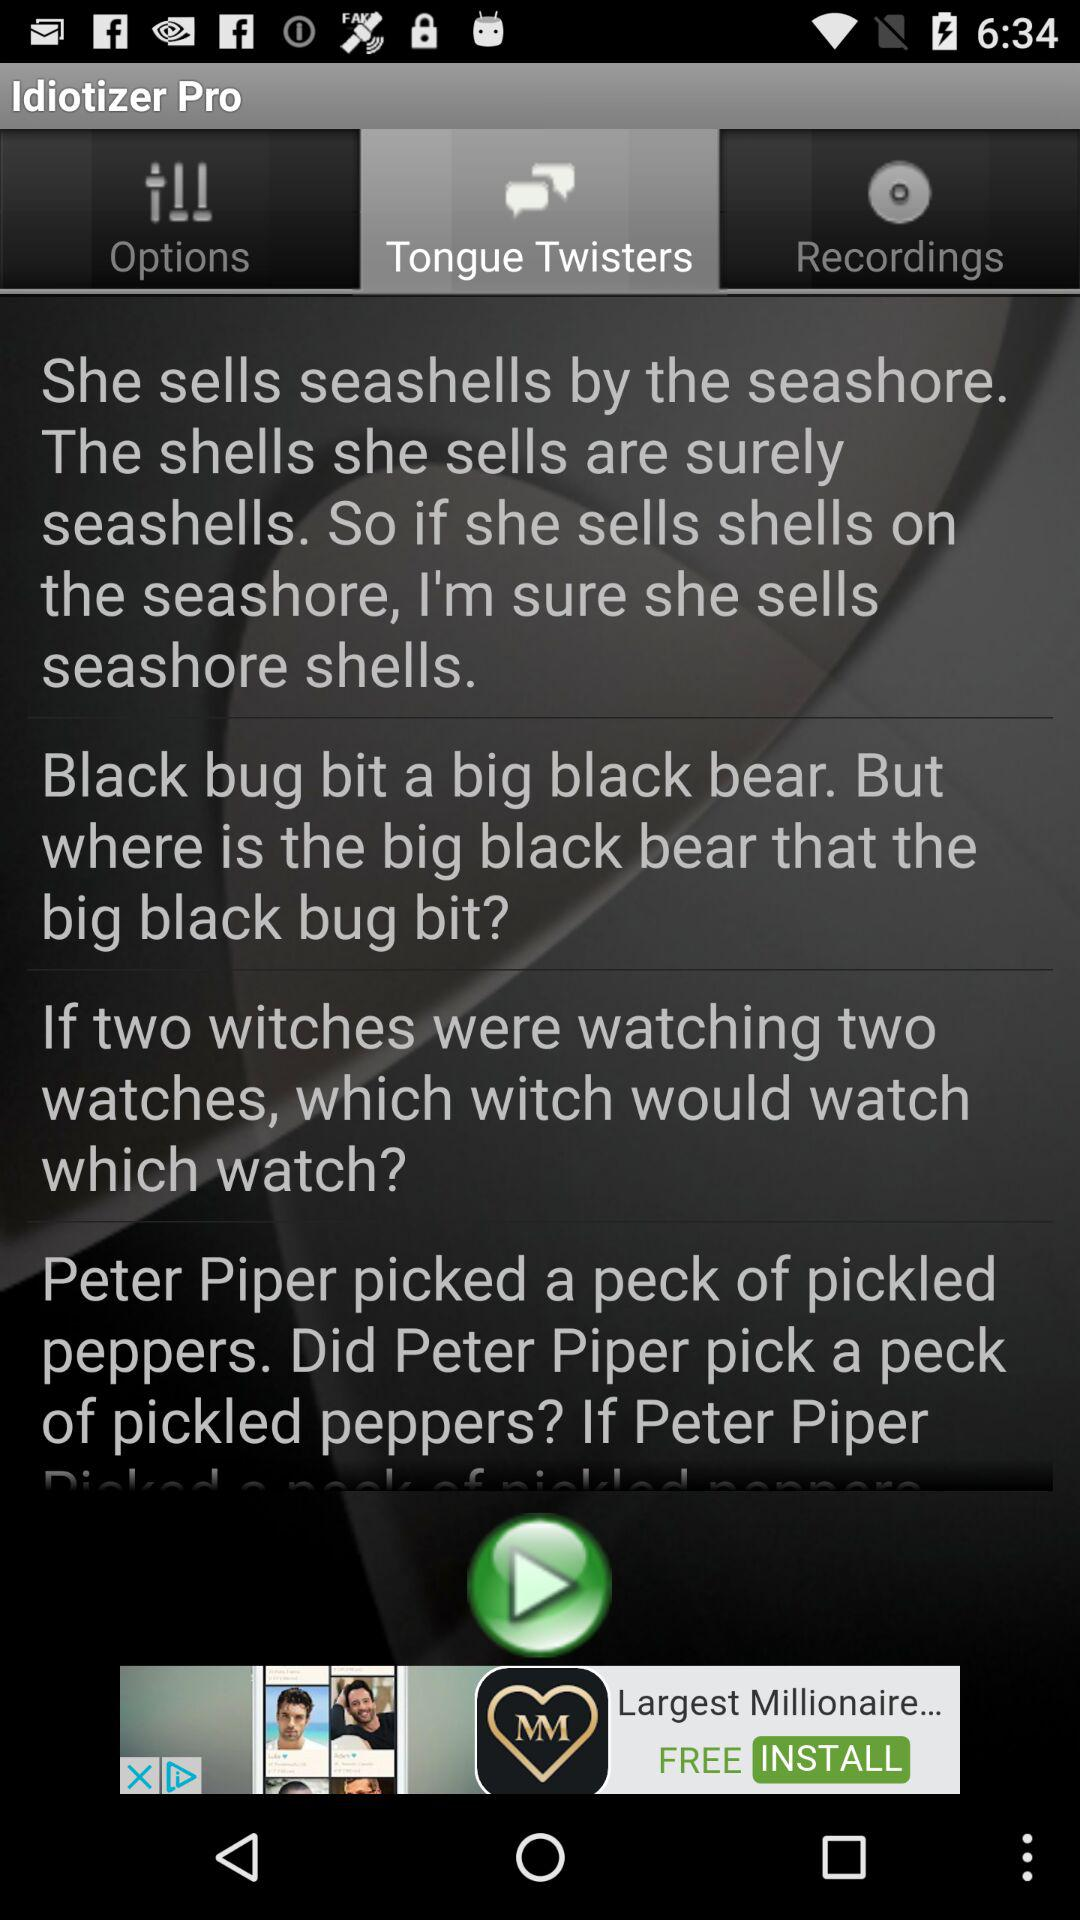How many riddles are there on the screen?
Answer the question using a single word or phrase. 4 